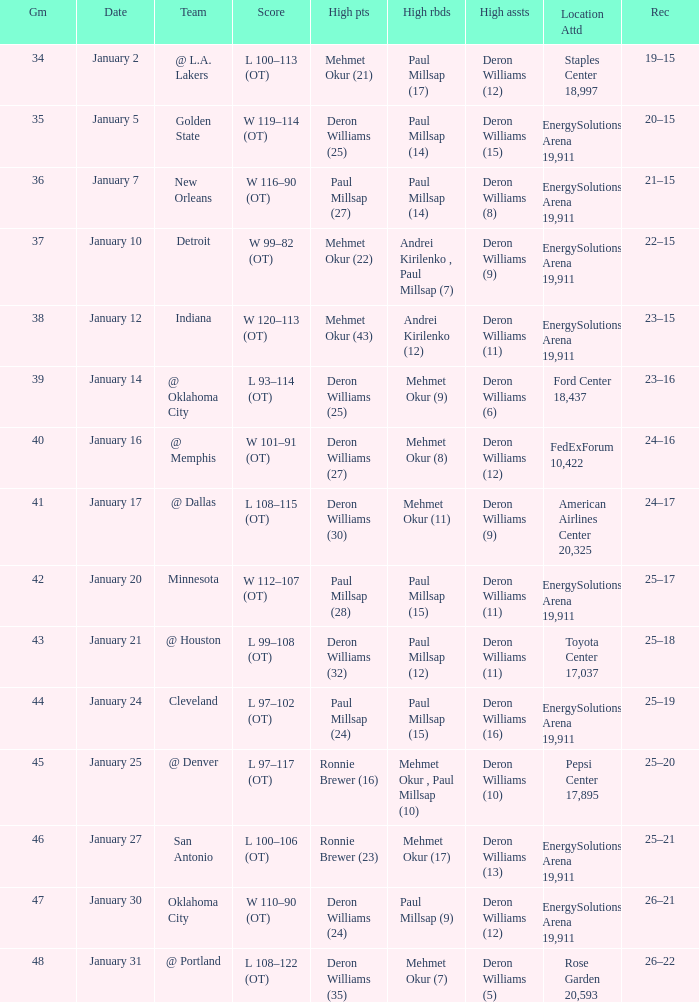What was the score of Game 48? L 108–122 (OT). 